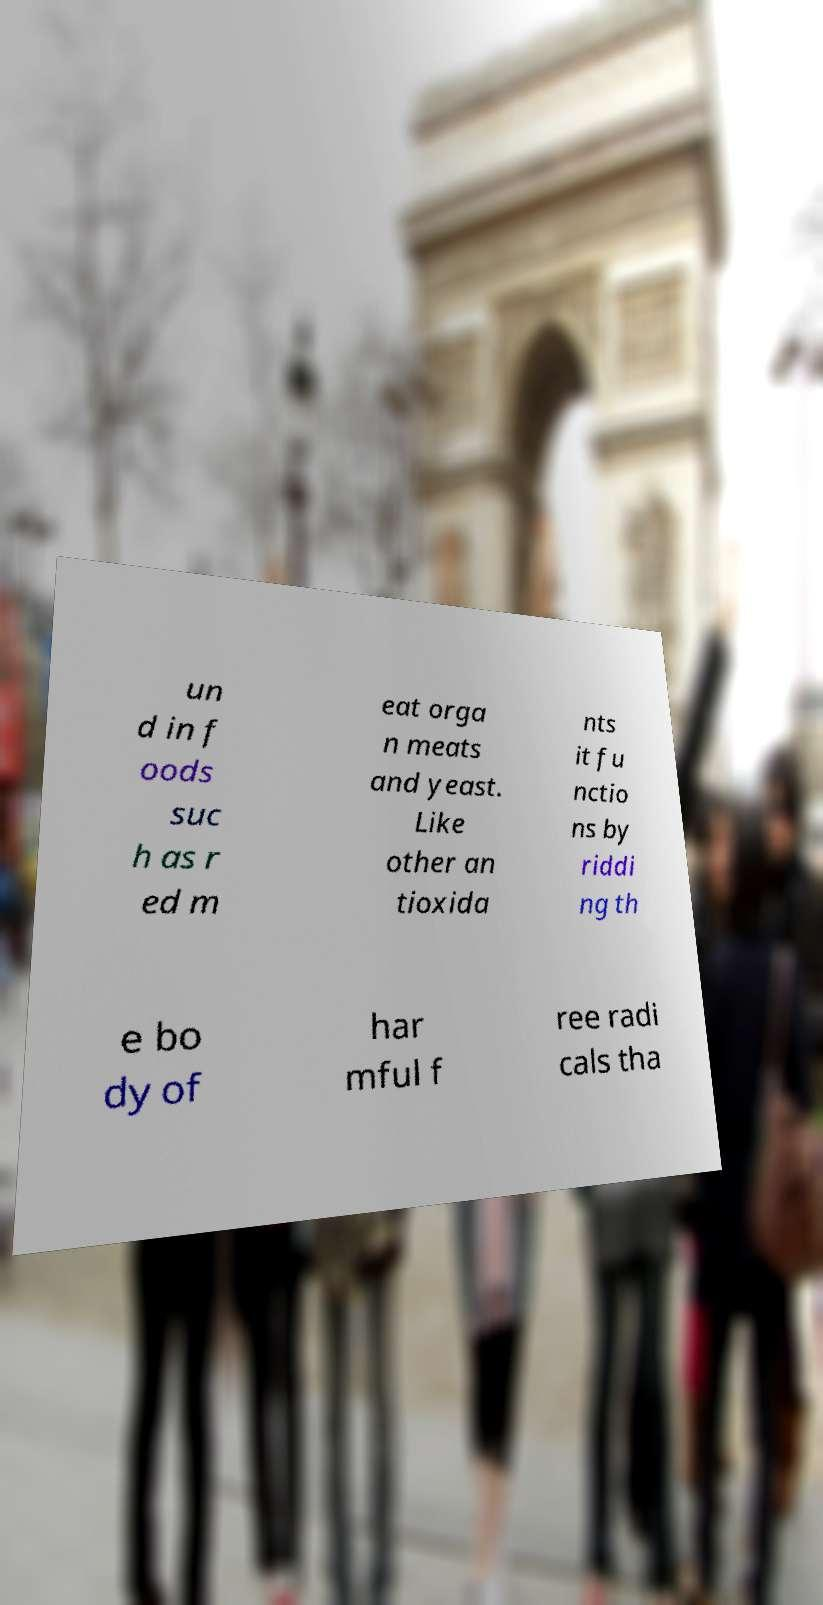I need the written content from this picture converted into text. Can you do that? un d in f oods suc h as r ed m eat orga n meats and yeast. Like other an tioxida nts it fu nctio ns by riddi ng th e bo dy of har mful f ree radi cals tha 